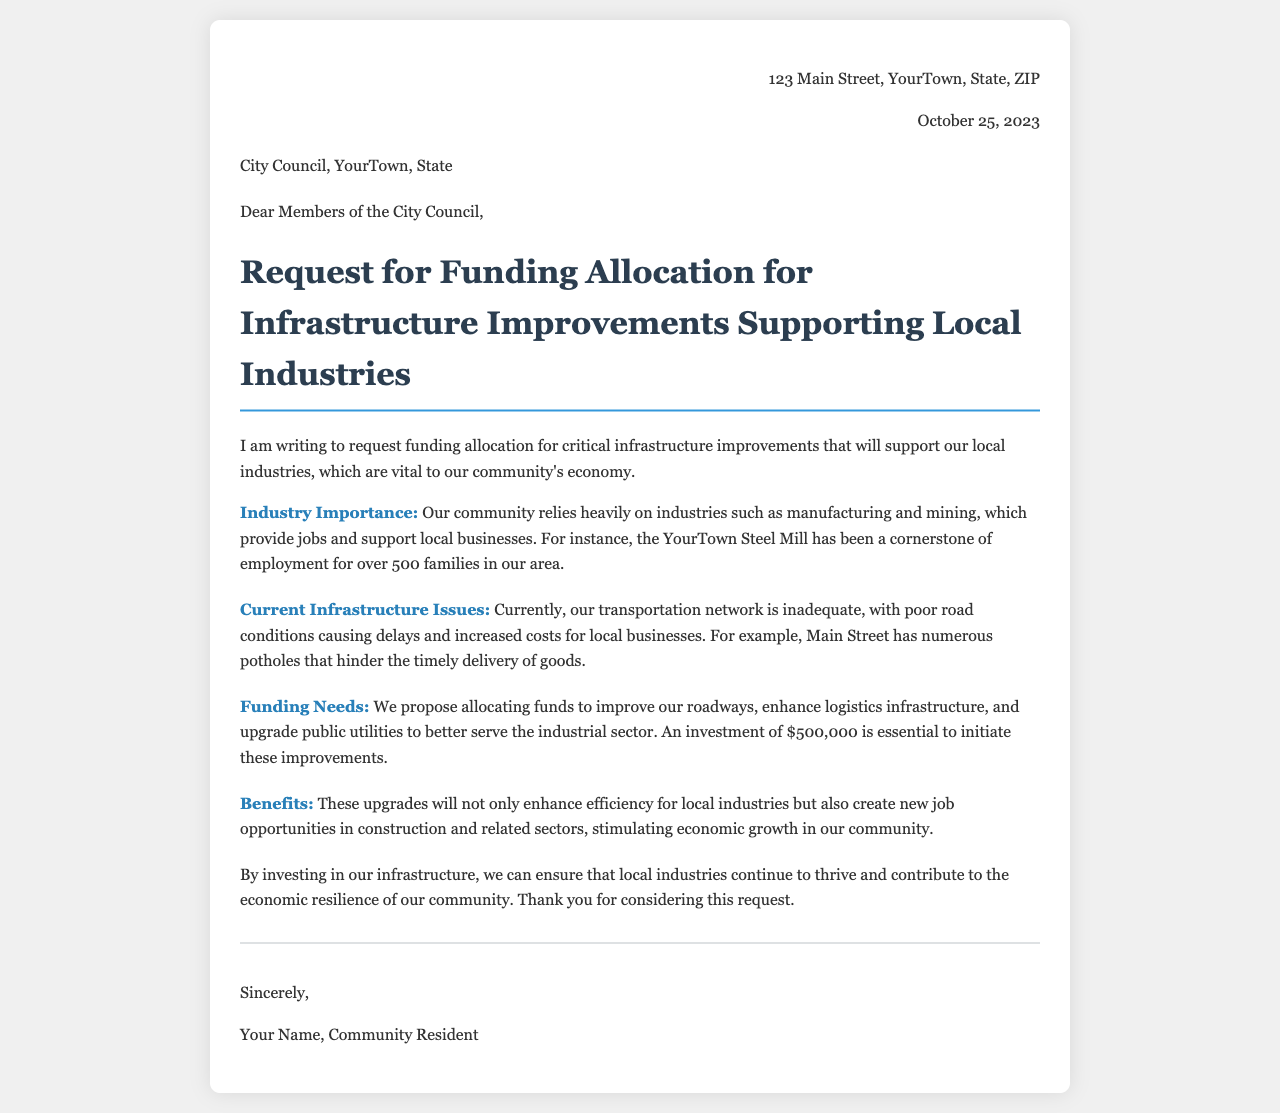What is the date of the letter? The date of the letter is indicated in the header as October 25, 2023.
Answer: October 25, 2023 Who is the recipient of the letter? The recipient of the letter, as stated in the document, is the City Council of YourTown, State.
Answer: City Council, YourTown, State What is the proposed funding amount for infrastructure improvements? The letter specifies a proposed funding amount of $500,000 for the infrastructure improvements.
Answer: $500,000 What is the main industry mentioned in the letter? The document mentions the YourTown Steel Mill as a primary industry supporting local employment.
Answer: YourTown Steel Mill What benefit does the letter claim will result from the infrastructure improvements? The letter states that the upgrades will create new job opportunities in construction and related sectors.
Answer: new job opportunities What issue is highlighted regarding the current transportation network? The letter notes that poor road conditions are causing delays and increased costs for local businesses.
Answer: poor road conditions Why is the funding needed, according to the letter? The funding is needed to improve roadways, enhance logistics infrastructure, and upgrade public utilities.
Answer: improve roadways, enhance logistics infrastructure, and upgrade public utilities What does the document suggest will be stimulated by the infrastructure investment? The document suggests that economic growth in the community will be stimulated by the infrastructure investment.
Answer: economic growth What is the tone of the letter? The tone of the letter is formal and requests support for local industries and infrastructure improvements.
Answer: formal 